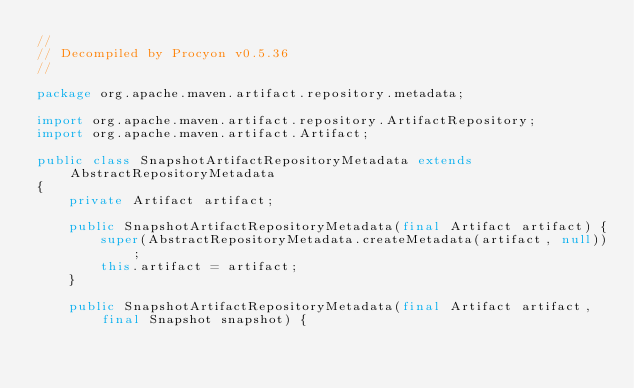<code> <loc_0><loc_0><loc_500><loc_500><_Java_>// 
// Decompiled by Procyon v0.5.36
// 

package org.apache.maven.artifact.repository.metadata;

import org.apache.maven.artifact.repository.ArtifactRepository;
import org.apache.maven.artifact.Artifact;

public class SnapshotArtifactRepositoryMetadata extends AbstractRepositoryMetadata
{
    private Artifact artifact;
    
    public SnapshotArtifactRepositoryMetadata(final Artifact artifact) {
        super(AbstractRepositoryMetadata.createMetadata(artifact, null));
        this.artifact = artifact;
    }
    
    public SnapshotArtifactRepositoryMetadata(final Artifact artifact, final Snapshot snapshot) {</code> 